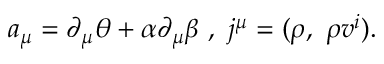Convert formula to latex. <formula><loc_0><loc_0><loc_500><loc_500>a _ { \mu } = \partial _ { \mu } \theta + \alpha \partial _ { \mu } \beta , j ^ { \mu } = ( \rho , \rho v ^ { i } ) .</formula> 